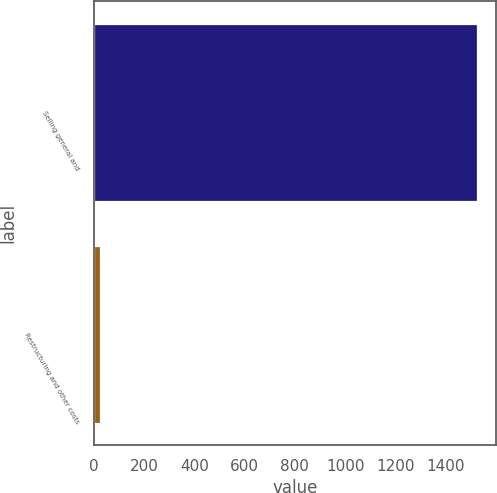<chart> <loc_0><loc_0><loc_500><loc_500><bar_chart><fcel>Selling general and<fcel>Restructuring and other costs<nl><fcel>1523<fcel>23.2<nl></chart> 